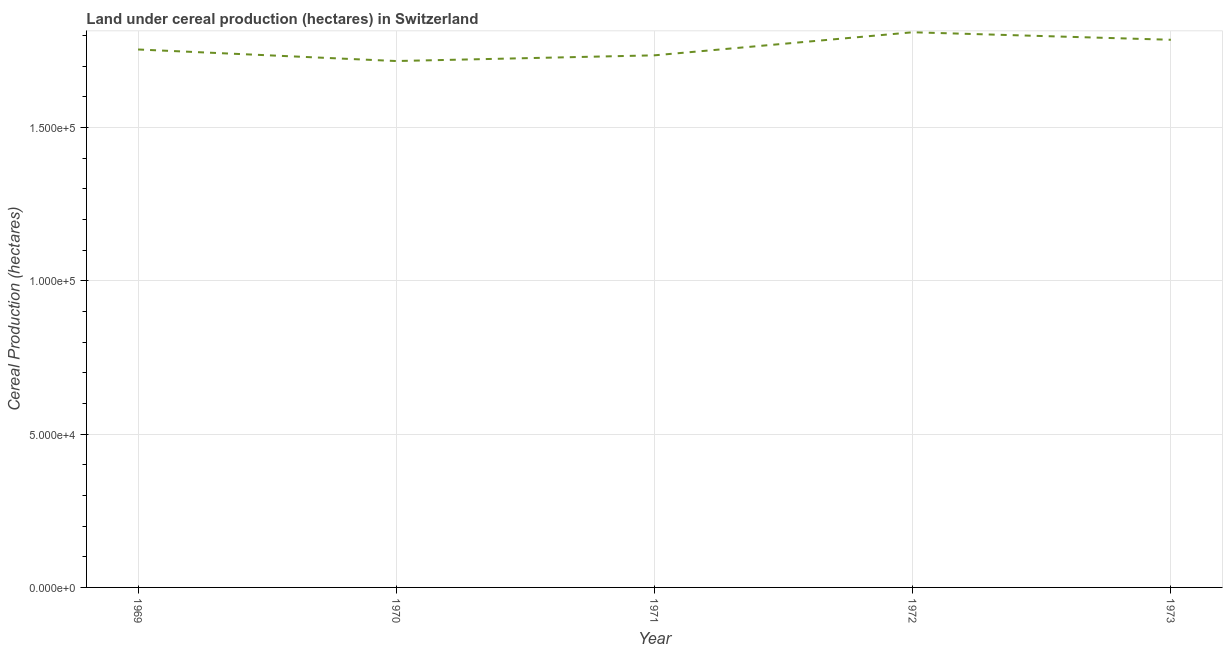What is the land under cereal production in 1973?
Ensure brevity in your answer.  1.79e+05. Across all years, what is the maximum land under cereal production?
Your response must be concise. 1.81e+05. Across all years, what is the minimum land under cereal production?
Provide a succinct answer. 1.72e+05. In which year was the land under cereal production maximum?
Offer a terse response. 1972. What is the sum of the land under cereal production?
Your response must be concise. 8.80e+05. What is the difference between the land under cereal production in 1969 and 1973?
Your answer should be very brief. -3165. What is the average land under cereal production per year?
Provide a succinct answer. 1.76e+05. What is the median land under cereal production?
Provide a succinct answer. 1.75e+05. In how many years, is the land under cereal production greater than 50000 hectares?
Provide a succinct answer. 5. Do a majority of the years between 1971 and 1969 (inclusive) have land under cereal production greater than 160000 hectares?
Your answer should be very brief. No. What is the ratio of the land under cereal production in 1972 to that in 1973?
Offer a very short reply. 1.01. Is the difference between the land under cereal production in 1970 and 1972 greater than the difference between any two years?
Provide a short and direct response. Yes. What is the difference between the highest and the second highest land under cereal production?
Offer a very short reply. 2450. What is the difference between the highest and the lowest land under cereal production?
Provide a succinct answer. 9380. What is the difference between two consecutive major ticks on the Y-axis?
Keep it short and to the point. 5.00e+04. Does the graph contain any zero values?
Provide a succinct answer. No. What is the title of the graph?
Offer a very short reply. Land under cereal production (hectares) in Switzerland. What is the label or title of the X-axis?
Give a very brief answer. Year. What is the label or title of the Y-axis?
Offer a terse response. Cereal Production (hectares). What is the Cereal Production (hectares) in 1969?
Ensure brevity in your answer.  1.75e+05. What is the Cereal Production (hectares) in 1970?
Provide a succinct answer. 1.72e+05. What is the Cereal Production (hectares) in 1971?
Your answer should be compact. 1.73e+05. What is the Cereal Production (hectares) in 1972?
Offer a very short reply. 1.81e+05. What is the Cereal Production (hectares) of 1973?
Provide a succinct answer. 1.79e+05. What is the difference between the Cereal Production (hectares) in 1969 and 1970?
Offer a terse response. 3765. What is the difference between the Cereal Production (hectares) in 1969 and 1971?
Ensure brevity in your answer.  1905. What is the difference between the Cereal Production (hectares) in 1969 and 1972?
Give a very brief answer. -5615. What is the difference between the Cereal Production (hectares) in 1969 and 1973?
Give a very brief answer. -3165. What is the difference between the Cereal Production (hectares) in 1970 and 1971?
Your answer should be compact. -1860. What is the difference between the Cereal Production (hectares) in 1970 and 1972?
Your response must be concise. -9380. What is the difference between the Cereal Production (hectares) in 1970 and 1973?
Make the answer very short. -6930. What is the difference between the Cereal Production (hectares) in 1971 and 1972?
Offer a very short reply. -7520. What is the difference between the Cereal Production (hectares) in 1971 and 1973?
Your response must be concise. -5070. What is the difference between the Cereal Production (hectares) in 1972 and 1973?
Ensure brevity in your answer.  2450. What is the ratio of the Cereal Production (hectares) in 1969 to that in 1972?
Offer a terse response. 0.97. What is the ratio of the Cereal Production (hectares) in 1970 to that in 1972?
Your answer should be very brief. 0.95. What is the ratio of the Cereal Production (hectares) in 1970 to that in 1973?
Ensure brevity in your answer.  0.96. What is the ratio of the Cereal Production (hectares) in 1971 to that in 1972?
Provide a succinct answer. 0.96. 